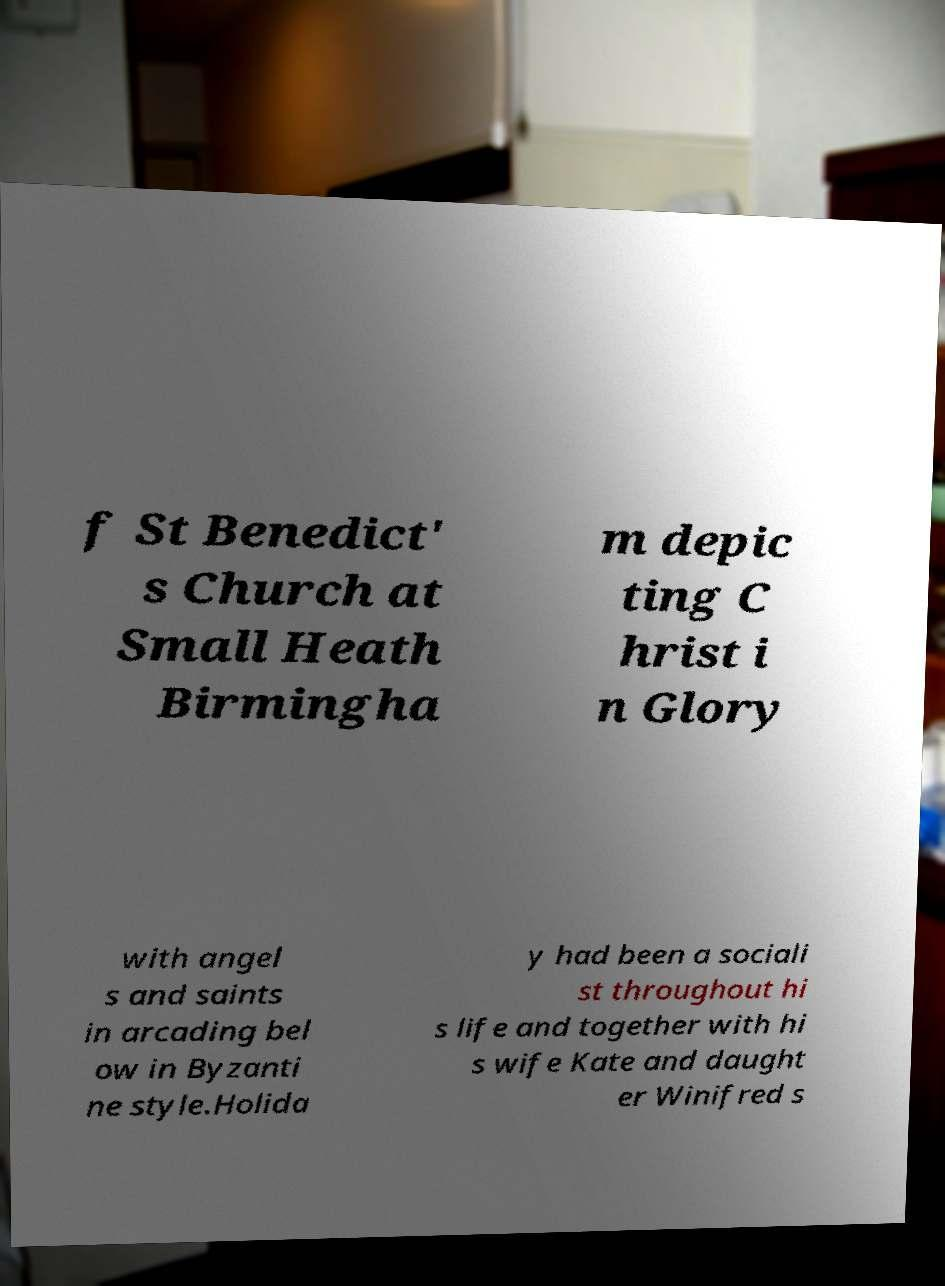Could you assist in decoding the text presented in this image and type it out clearly? f St Benedict' s Church at Small Heath Birmingha m depic ting C hrist i n Glory with angel s and saints in arcading bel ow in Byzanti ne style.Holida y had been a sociali st throughout hi s life and together with hi s wife Kate and daught er Winifred s 